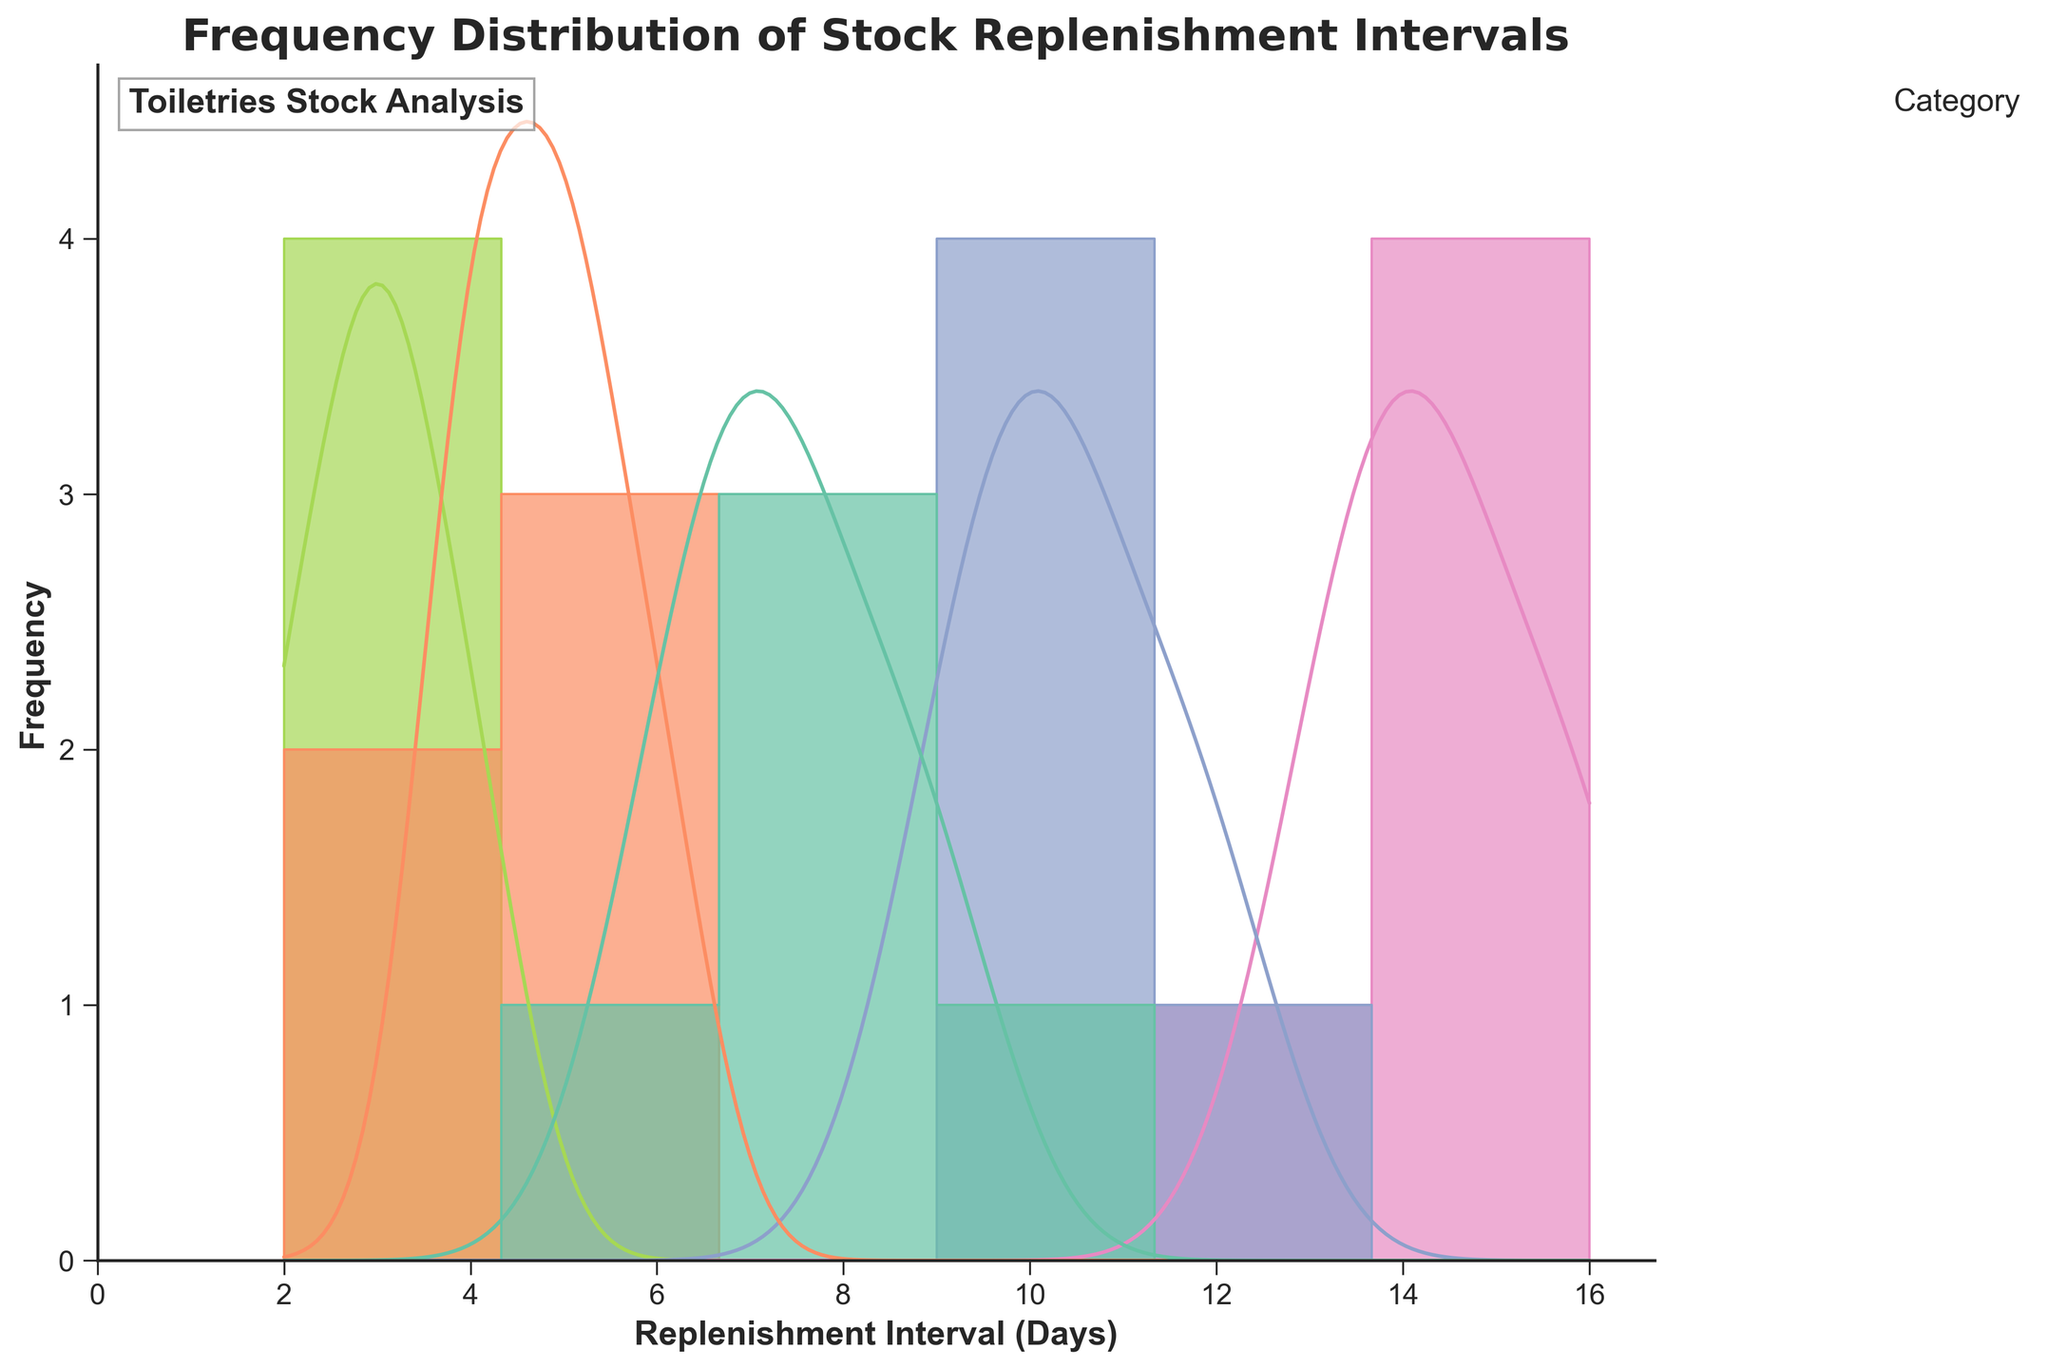What is the title of the histogram? The title is given at the top of the histogram in bold font.
Answer: Frequency Distribution of Stock Replenishment Intervals What category has the highest concentration of replenishment intervals around 14 days? By examining the colors and the KDE (density curve) peaks around 14 days, the category 'Deodorant' stands out.
Answer: Deodorant How often is toilet paper replenished on average compared to shampoo? By comparing the frequency distributions, Toilet paper is replenished more frequently (closer to the left side) compared to Shampoo.
Answer: More frequently What's the range of the x-axis? The x-axis represents the replenishment intervals in days, ranging from 0 to the maximum interval observed in the data, which is 16 days.
Answer: 0 to 16 days Which category appears to have the most varied replenishment intervals? Looking at the histogram's spread of different categories, 'Toothpaste' shows a wider range of replenishment intervals compared to others.
Answer: Toothpaste How frequently is soap replenished within 5 days? Referring to the histogram, Soap has significant frequencies around 4 and 5 days based on the bar height and KDE curve.
Answer: Frequently Which category has the highest peak in the density curve (KDE) at the 9 day mark? Observing the peaks of the KDE curves around 9 days, 'Shampoo' shows the highest peak at this interval.
Answer: Shampoo Compare the replenishment intervals of Shampoo and Deodorant. Which has a larger spread? Evaluating the width of the histograms, Deodorant exhibits a wider spread of replenishment intervals compared to Shampoo.
Answer: Deodorant 